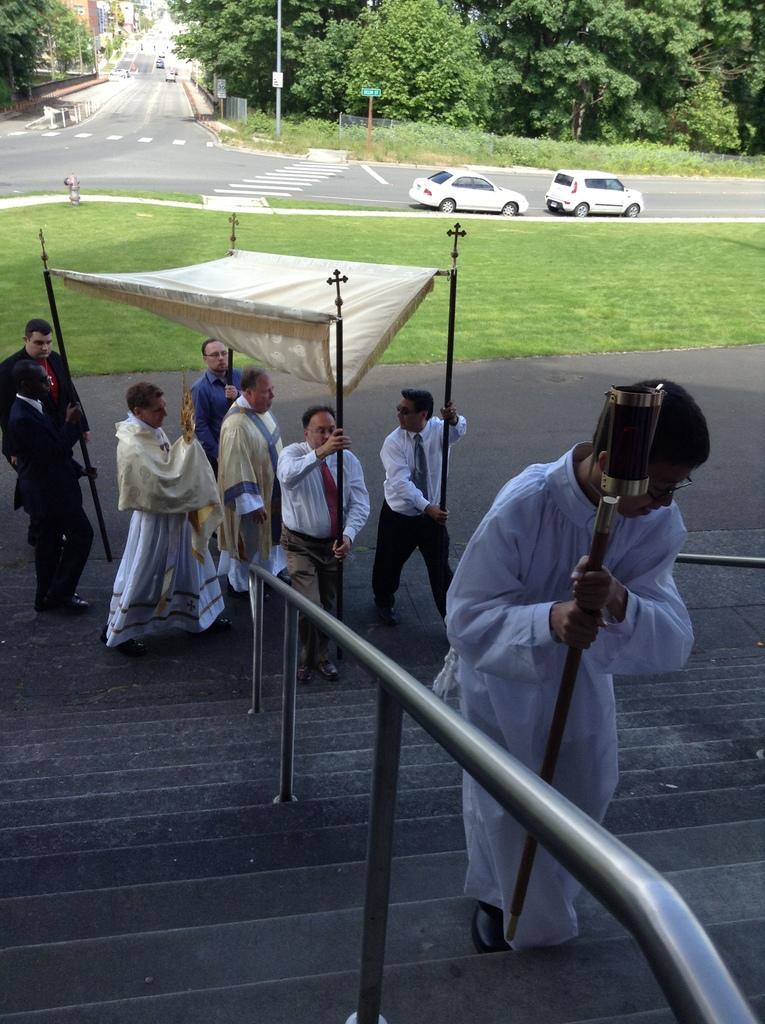Could you give a brief overview of what you see in this image? In this image I can see there four persons holding sticks and there are two persons walking on the road under the tent , in the foreground I can see a person holding a stick , standing on the stair case and at the top I can see a road and vehicles and trees and poles. 